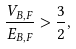<formula> <loc_0><loc_0><loc_500><loc_500>\frac { V _ { B , F } } { E _ { B , F } } > \frac { 3 } { 2 } ,</formula> 